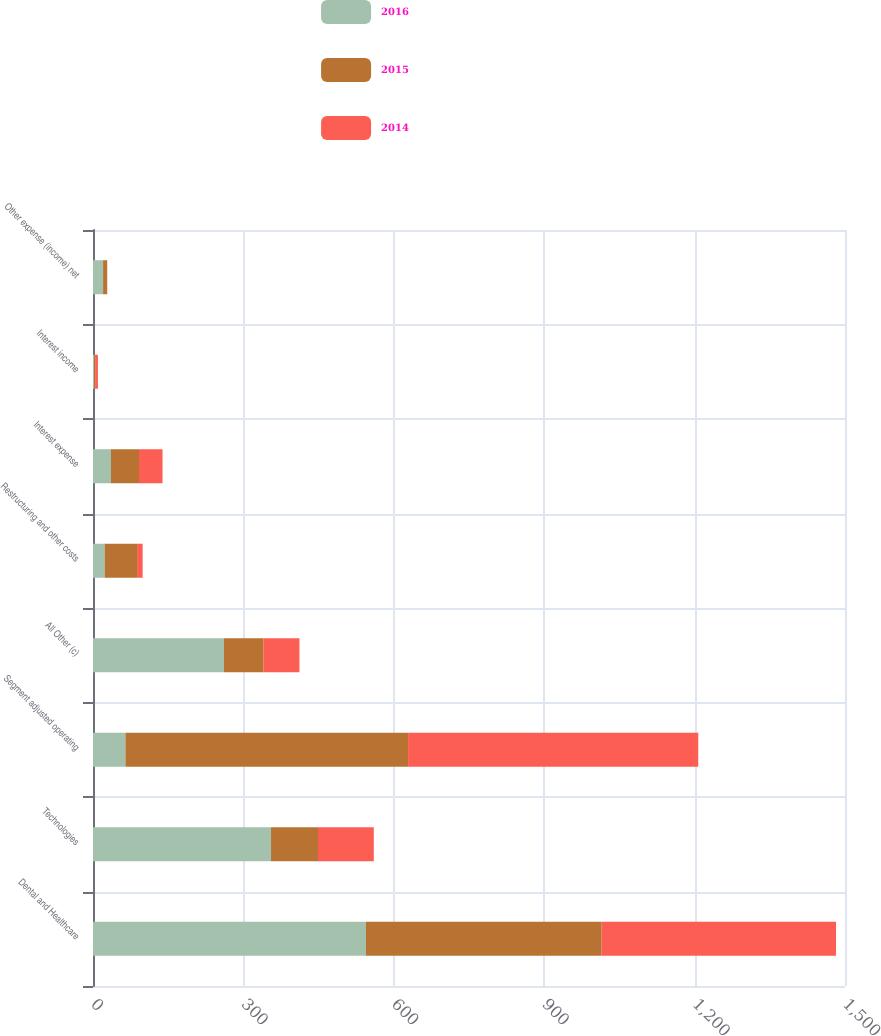<chart> <loc_0><loc_0><loc_500><loc_500><stacked_bar_chart><ecel><fcel>Dental and Healthcare<fcel>Technologies<fcel>Segment adjusted operating<fcel>All Other (c)<fcel>Restructuring and other costs<fcel>Interest expense<fcel>Interest income<fcel>Other expense (income) net<nl><fcel>2016<fcel>544.5<fcel>355.1<fcel>64.7<fcel>261.3<fcel>23.2<fcel>35.9<fcel>2<fcel>20.1<nl><fcel>2015<fcel>470.1<fcel>93.7<fcel>563.8<fcel>78.4<fcel>64.7<fcel>55.9<fcel>2.2<fcel>8.2<nl><fcel>2014<fcel>467.5<fcel>111.3<fcel>578.8<fcel>72.1<fcel>11.1<fcel>46.9<fcel>5.6<fcel>0.1<nl></chart> 